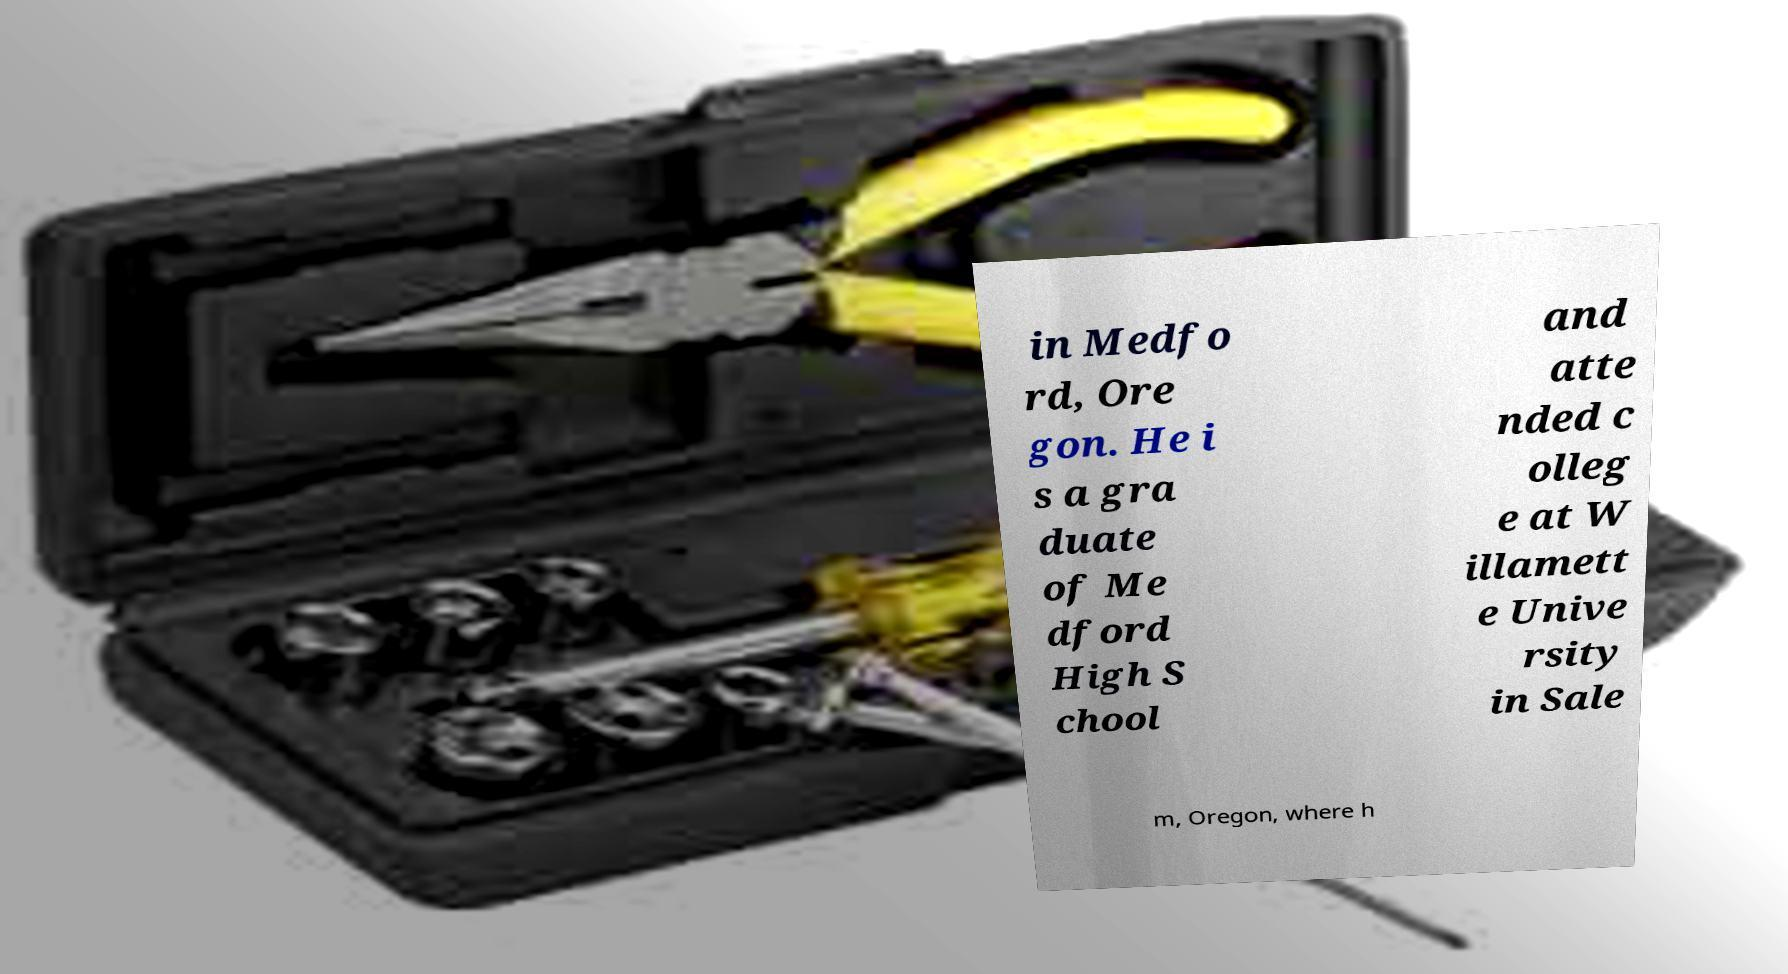I need the written content from this picture converted into text. Can you do that? in Medfo rd, Ore gon. He i s a gra duate of Me dford High S chool and atte nded c olleg e at W illamett e Unive rsity in Sale m, Oregon, where h 